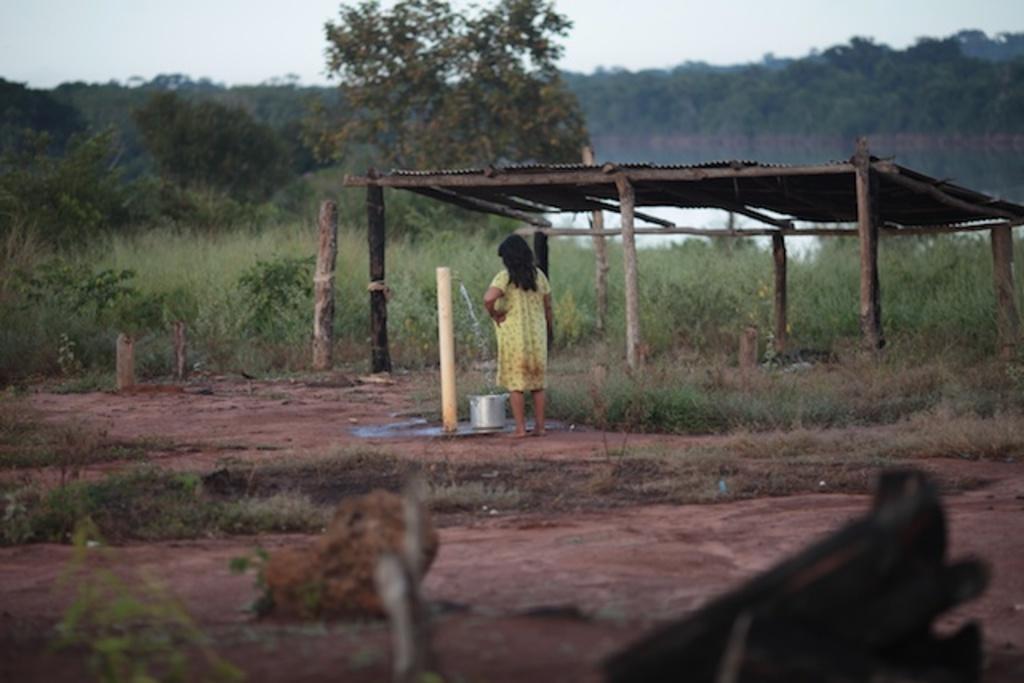Describe this image in one or two sentences. In this image there is a person standing, there is a tap , water , a bowl on the ground, there is a shed, there are plants and trees, and in the background there is sky. 